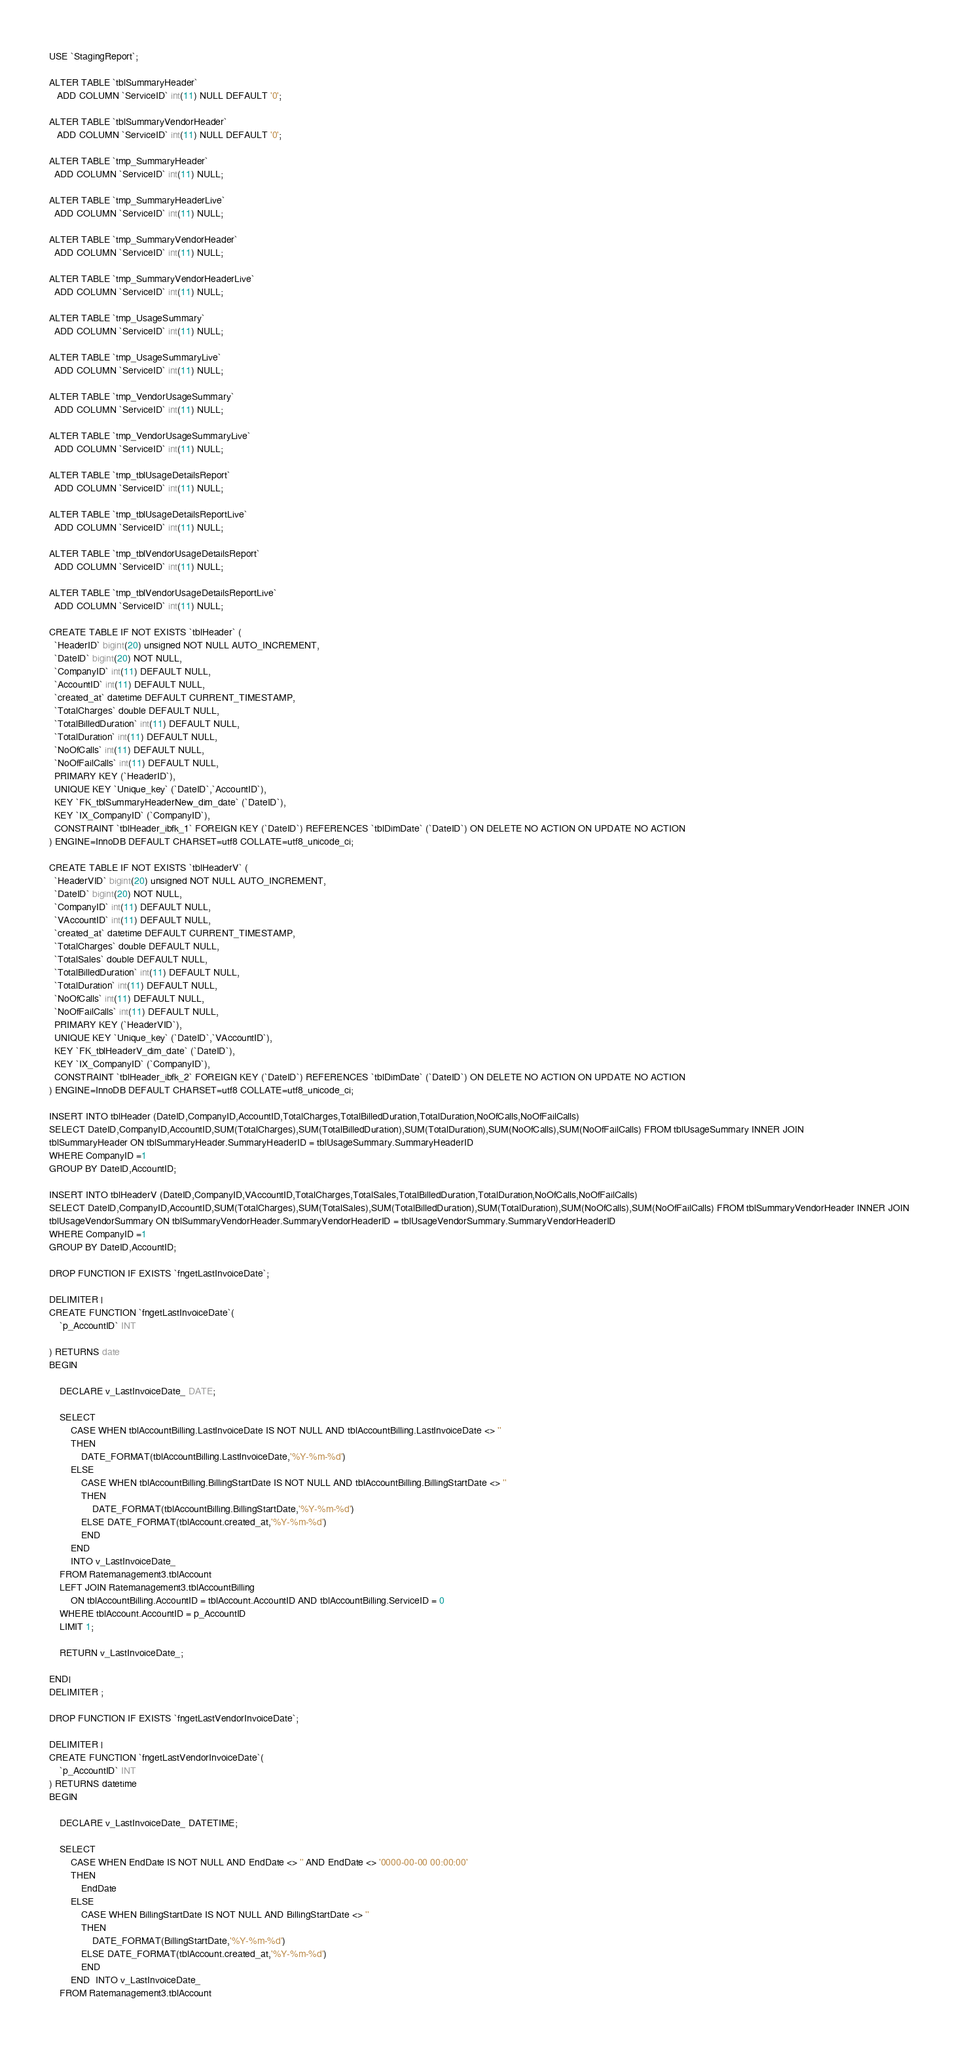<code> <loc_0><loc_0><loc_500><loc_500><_SQL_>USE `StagingReport`;

ALTER TABLE `tblSummaryHeader`
   ADD COLUMN `ServiceID` int(11) NULL DEFAULT '0';

ALTER TABLE `tblSummaryVendorHeader`
   ADD COLUMN `ServiceID` int(11) NULL DEFAULT '0';

ALTER TABLE `tmp_SummaryHeader`
  ADD COLUMN `ServiceID` int(11) NULL;

ALTER TABLE `tmp_SummaryHeaderLive`
  ADD COLUMN `ServiceID` int(11) NULL;

ALTER TABLE `tmp_SummaryVendorHeader`
  ADD COLUMN `ServiceID` int(11) NULL;

ALTER TABLE `tmp_SummaryVendorHeaderLive`
  ADD COLUMN `ServiceID` int(11) NULL;

ALTER TABLE `tmp_UsageSummary`
  ADD COLUMN `ServiceID` int(11) NULL;

ALTER TABLE `tmp_UsageSummaryLive`
  ADD COLUMN `ServiceID` int(11) NULL;

ALTER TABLE `tmp_VendorUsageSummary`
  ADD COLUMN `ServiceID` int(11) NULL;

ALTER TABLE `tmp_VendorUsageSummaryLive`
  ADD COLUMN `ServiceID` int(11) NULL;

ALTER TABLE `tmp_tblUsageDetailsReport`
  ADD COLUMN `ServiceID` int(11) NULL;

ALTER TABLE `tmp_tblUsageDetailsReportLive`
  ADD COLUMN `ServiceID` int(11) NULL;

ALTER TABLE `tmp_tblVendorUsageDetailsReport`
  ADD COLUMN `ServiceID` int(11) NULL;

ALTER TABLE `tmp_tblVendorUsageDetailsReportLive`
  ADD COLUMN `ServiceID` int(11) NULL;

CREATE TABLE IF NOT EXISTS `tblHeader` (
  `HeaderID` bigint(20) unsigned NOT NULL AUTO_INCREMENT,
  `DateID` bigint(20) NOT NULL,
  `CompanyID` int(11) DEFAULT NULL,
  `AccountID` int(11) DEFAULT NULL,
  `created_at` datetime DEFAULT CURRENT_TIMESTAMP,
  `TotalCharges` double DEFAULT NULL,
  `TotalBilledDuration` int(11) DEFAULT NULL,
  `TotalDuration` int(11) DEFAULT NULL,
  `NoOfCalls` int(11) DEFAULT NULL,
  `NoOfFailCalls` int(11) DEFAULT NULL,
  PRIMARY KEY (`HeaderID`),
  UNIQUE KEY `Unique_key` (`DateID`,`AccountID`),
  KEY `FK_tblSummaryHeaderNew_dim_date` (`DateID`),
  KEY `IX_CompanyID` (`CompanyID`),
  CONSTRAINT `tblHeader_ibfk_1` FOREIGN KEY (`DateID`) REFERENCES `tblDimDate` (`DateID`) ON DELETE NO ACTION ON UPDATE NO ACTION
) ENGINE=InnoDB DEFAULT CHARSET=utf8 COLLATE=utf8_unicode_ci;

CREATE TABLE IF NOT EXISTS `tblHeaderV` (
  `HeaderVID` bigint(20) unsigned NOT NULL AUTO_INCREMENT,
  `DateID` bigint(20) NOT NULL,
  `CompanyID` int(11) DEFAULT NULL,
  `VAccountID` int(11) DEFAULT NULL,
  `created_at` datetime DEFAULT CURRENT_TIMESTAMP,
  `TotalCharges` double DEFAULT NULL,
  `TotalSales` double DEFAULT NULL,
  `TotalBilledDuration` int(11) DEFAULT NULL,
  `TotalDuration` int(11) DEFAULT NULL,
  `NoOfCalls` int(11) DEFAULT NULL,
  `NoOfFailCalls` int(11) DEFAULT NULL,
  PRIMARY KEY (`HeaderVID`),
  UNIQUE KEY `Unique_key` (`DateID`,`VAccountID`),
  KEY `FK_tblHeaderV_dim_date` (`DateID`),
  KEY `IX_CompanyID` (`CompanyID`),
  CONSTRAINT `tblHeader_ibfk_2` FOREIGN KEY (`DateID`) REFERENCES `tblDimDate` (`DateID`) ON DELETE NO ACTION ON UPDATE NO ACTION
) ENGINE=InnoDB DEFAULT CHARSET=utf8 COLLATE=utf8_unicode_ci;  

INSERT INTO tblHeader (DateID,CompanyID,AccountID,TotalCharges,TotalBilledDuration,TotalDuration,NoOfCalls,NoOfFailCalls)
SELECT DateID,CompanyID,AccountID,SUM(TotalCharges),SUM(TotalBilledDuration),SUM(TotalDuration),SUM(NoOfCalls),SUM(NoOfFailCalls) FROM tblUsageSummary INNER JOIN 
tblSummaryHeader ON tblSummaryHeader.SummaryHeaderID = tblUsageSummary.SummaryHeaderID
WHERE CompanyID =1
GROUP BY DateID,AccountID;

INSERT INTO tblHeaderV (DateID,CompanyID,VAccountID,TotalCharges,TotalSales,TotalBilledDuration,TotalDuration,NoOfCalls,NoOfFailCalls)
SELECT DateID,CompanyID,AccountID,SUM(TotalCharges),SUM(TotalSales),SUM(TotalBilledDuration),SUM(TotalDuration),SUM(NoOfCalls),SUM(NoOfFailCalls) FROM tblSummaryVendorHeader INNER JOIN 
tblUsageVendorSummary ON tblSummaryVendorHeader.SummaryVendorHeaderID = tblUsageVendorSummary.SummaryVendorHeaderID
WHERE CompanyID =1
GROUP BY DateID,AccountID;
  
DROP FUNCTION IF EXISTS `fngetLastInvoiceDate`;

DELIMITER |
CREATE FUNCTION `fngetLastInvoiceDate`(
	`p_AccountID` INT

) RETURNS date
BEGIN
	
	DECLARE v_LastInvoiceDate_ DATE;
	
	SELECT 
		CASE WHEN tblAccountBilling.LastInvoiceDate IS NOT NULL AND tblAccountBilling.LastInvoiceDate <> '' 
		THEN 
			DATE_FORMAT(tblAccountBilling.LastInvoiceDate,'%Y-%m-%d')
		ELSE 
			CASE WHEN tblAccountBilling.BillingStartDate IS NOT NULL AND tblAccountBilling.BillingStartDate <> ''
			THEN
				DATE_FORMAT(tblAccountBilling.BillingStartDate,'%Y-%m-%d')
			ELSE DATE_FORMAT(tblAccount.created_at,'%Y-%m-%d')
			END 
		END
		INTO v_LastInvoiceDate_ 
	FROM Ratemanagement3.tblAccount
	LEFT JOIN Ratemanagement3.tblAccountBilling 
		ON tblAccountBilling.AccountID = tblAccount.AccountID AND tblAccountBilling.ServiceID = 0
	WHERE tblAccount.AccountID = p_AccountID
	LIMIT 1;
	
	RETURN v_LastInvoiceDate_;
	
END|
DELIMITER ;

DROP FUNCTION IF EXISTS `fngetLastVendorInvoiceDate`;

DELIMITER |
CREATE FUNCTION `fngetLastVendorInvoiceDate`(
	`p_AccountID` INT
) RETURNS datetime
BEGIN
	
	DECLARE v_LastInvoiceDate_ DATETIME;
	
	SELECT
		CASE WHEN EndDate IS NOT NULL AND EndDate <> '' AND EndDate <> '0000-00-00 00:00:00'
		THEN 
			EndDate
		ELSE 
			CASE WHEN BillingStartDate IS NOT NULL AND BillingStartDate <> ''
			THEN
				DATE_FORMAT(BillingStartDate,'%Y-%m-%d')
			ELSE DATE_FORMAT(tblAccount.created_at,'%Y-%m-%d')
			END 
		END  INTO v_LastInvoiceDate_
 	FROM Ratemanagement3.tblAccount</code> 